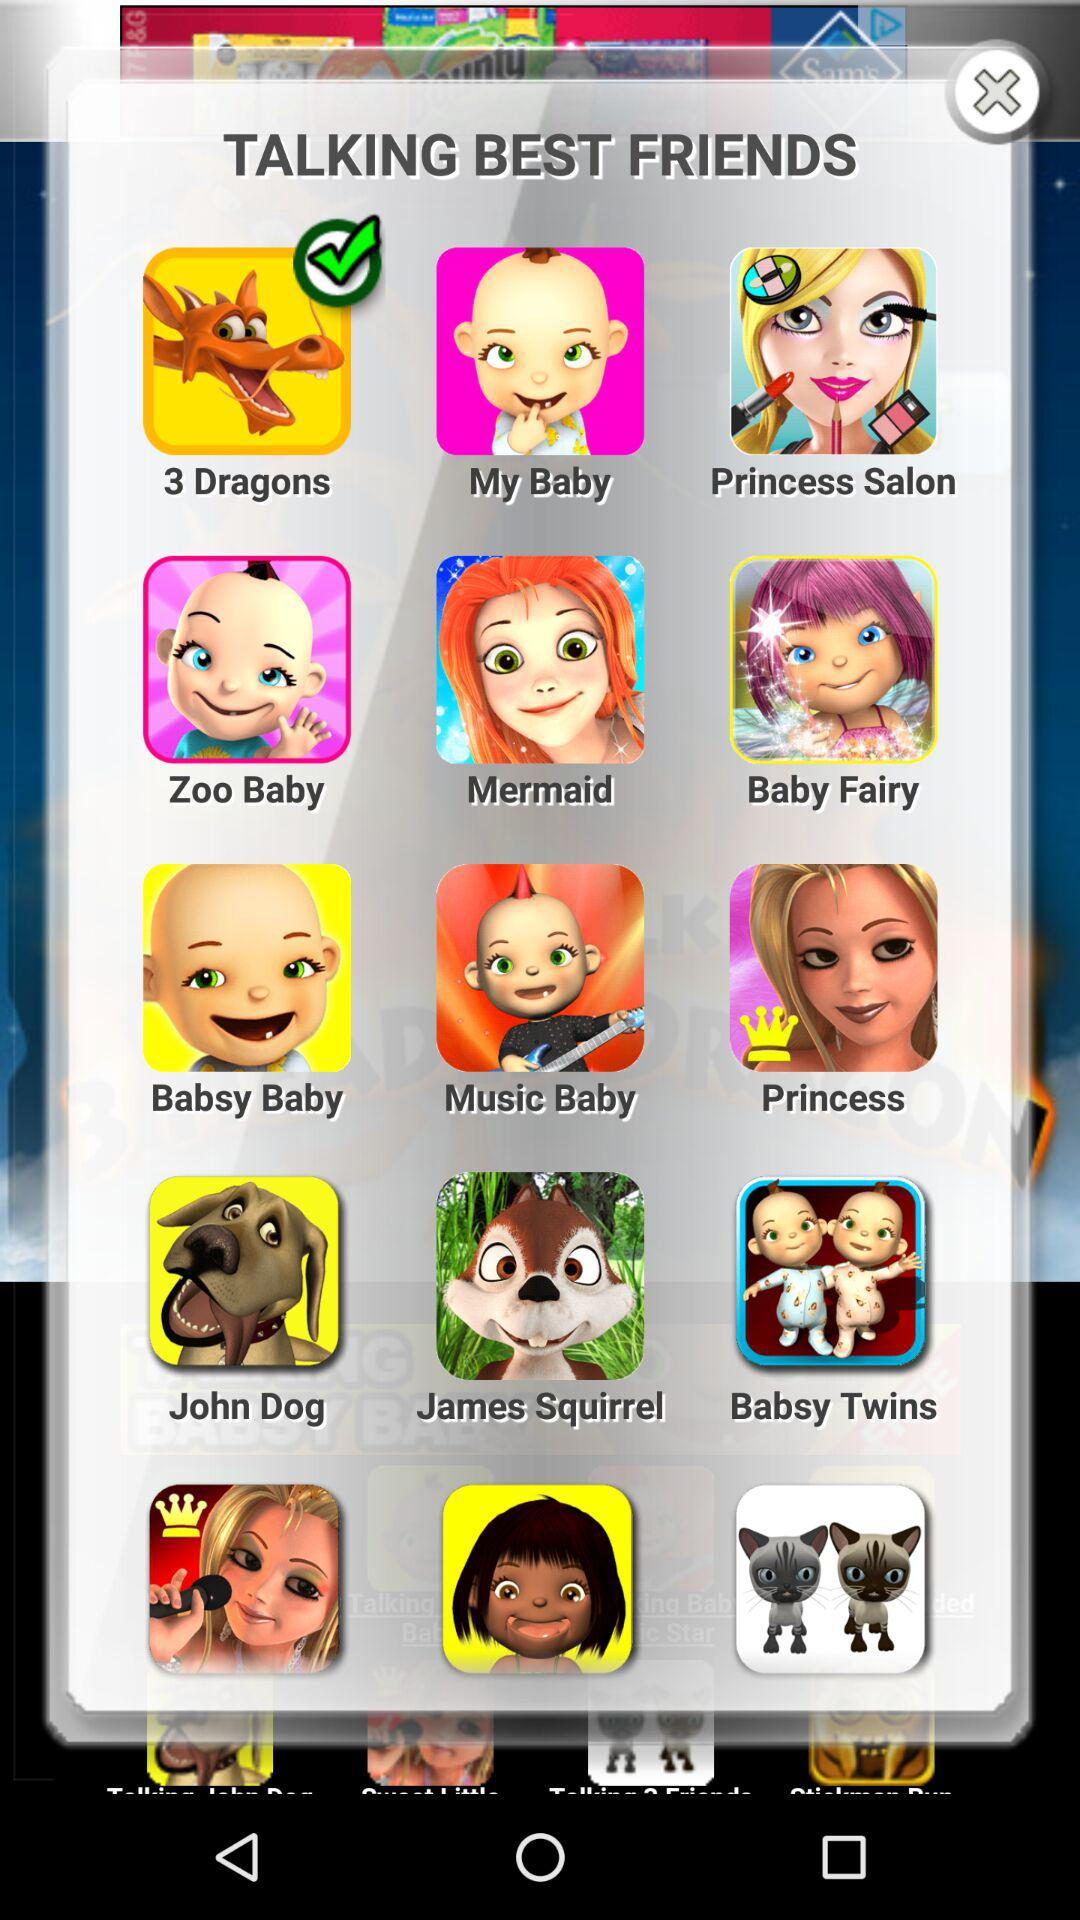How many talking best friends can be chosen?
When the provided information is insufficient, respond with <no answer>. <no answer> 